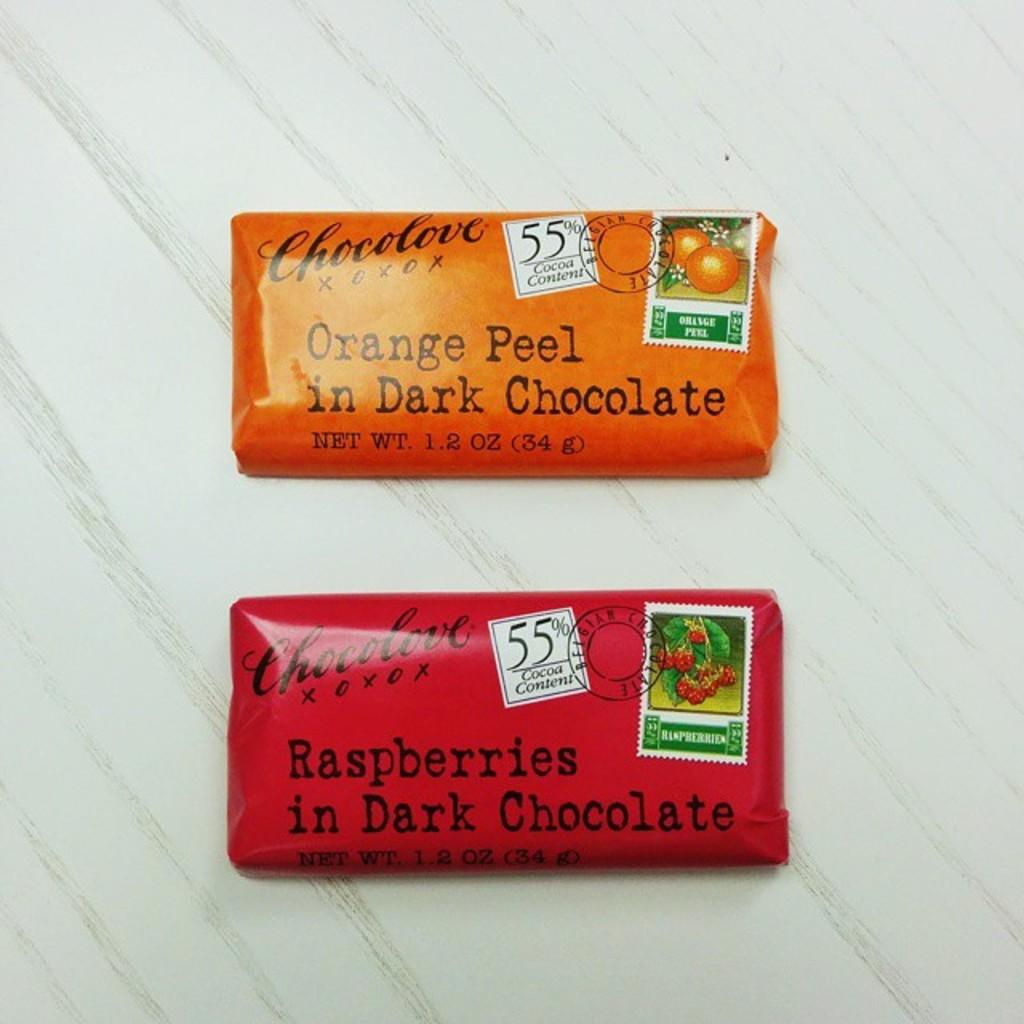<image>
Create a compact narrative representing the image presented. two Chocolove brand dark chocolates are sitting on a table. 